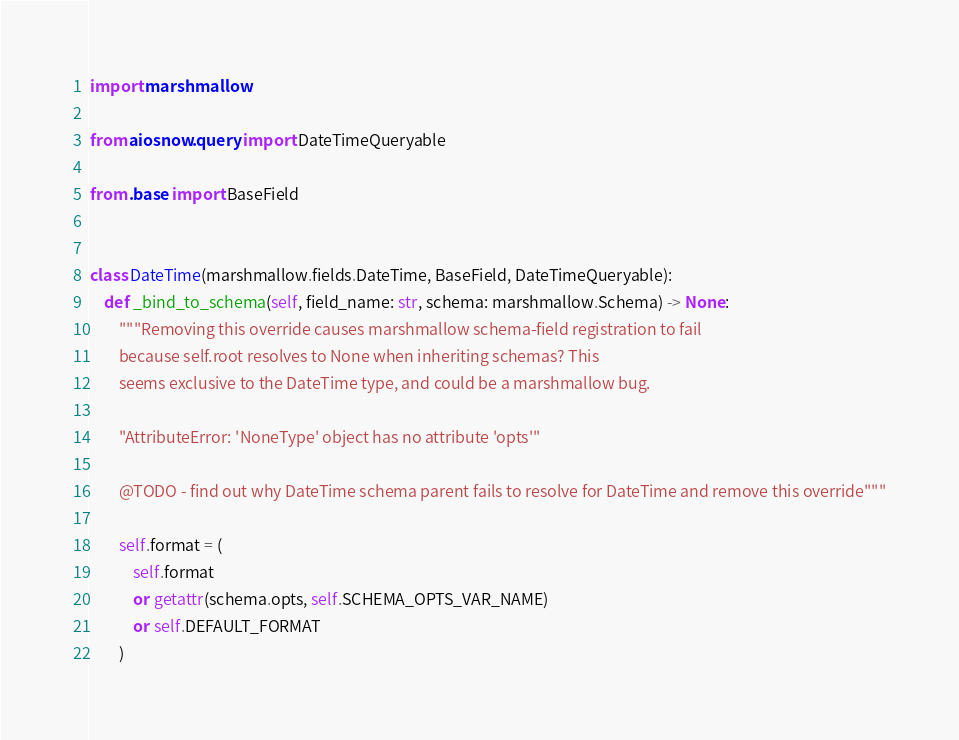<code> <loc_0><loc_0><loc_500><loc_500><_Python_>import marshmallow

from aiosnow.query import DateTimeQueryable

from .base import BaseField


class DateTime(marshmallow.fields.DateTime, BaseField, DateTimeQueryable):
    def _bind_to_schema(self, field_name: str, schema: marshmallow.Schema) -> None:
        """Removing this override causes marshmallow schema-field registration to fail
        because self.root resolves to None when inheriting schemas? This
        seems exclusive to the DateTime type, and could be a marshmallow bug.

        "AttributeError: 'NoneType' object has no attribute 'opts'"

        @TODO - find out why DateTime schema parent fails to resolve for DateTime and remove this override"""

        self.format = (
            self.format
            or getattr(schema.opts, self.SCHEMA_OPTS_VAR_NAME)
            or self.DEFAULT_FORMAT
        )
</code> 